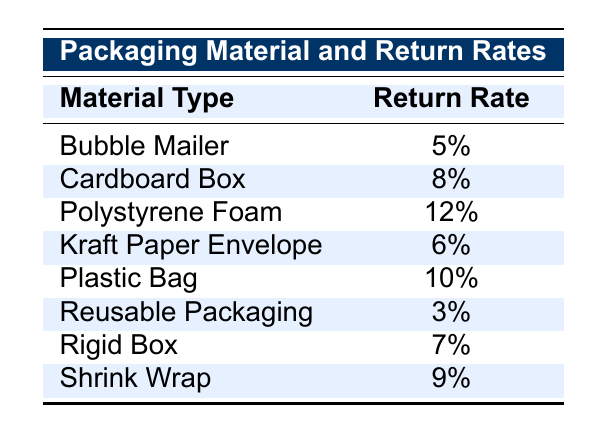What is the return rate for Reusable Packaging? The table directly shows that the return rate for Reusable Packaging is listed as 3%.
Answer: 3% Which packaging material has the highest return rate? From the table, Polystyrene Foam has the highest return rate, which is 12%.
Answer: Polystyrene Foam Is the return rate for a Bubble Mailer less than the return rate for a Plastic Bag? The return rate for a Bubble Mailer is 5%, whereas for a Plastic Bag it is 10%. Since 5% is less than 10%, the statement is true.
Answer: Yes What is the average return rate of the packaging materials listed in the table? To find the average return rate, first convert all rates from percentages to numerical values: 5, 8, 12, 6, 10, 3, 7, 9. Then, sum these values: 5 + 8 + 12 + 6 + 10 + 3 + 7 + 9 = 60. Since there are 8 materials, the average return rate is 60 / 8 = 7.5%.
Answer: 7.5% Is the return rate for Kraft Paper Envelope lower than that for Cardboard Box? The return rate for Kraft Paper Envelope is 6%, and for Cardboard Box, it is 8%. Since 6% is lower than 8%, the statement is true.
Answer: Yes What is the difference in return rates between Rigid Box and Shrink Wrap? Rigid Box has a return rate of 7% and Shrink Wrap has a return rate of 9%. The difference in rates is calculated as 9% - 7% = 2%.
Answer: 2% How many packaging materials have a return rate of 8% or more? The materials with return rates of 8% or more are Cardboard Box (8%), Polystyrene Foam (12%), Plastic Bag (10%), and Shrink Wrap (9%). Counting these gives us a total of 4 materials.
Answer: 4 What is the return rate for Kraft Paper Envelope if we compare it to the average return rate? The return rate for Kraft Paper Envelope is 6%, while the average return rate is 7.5%. Since 6% is less than 7.5%, Kraft Paper Envelope has a return rate lower than the average.
Answer: Lower than average 